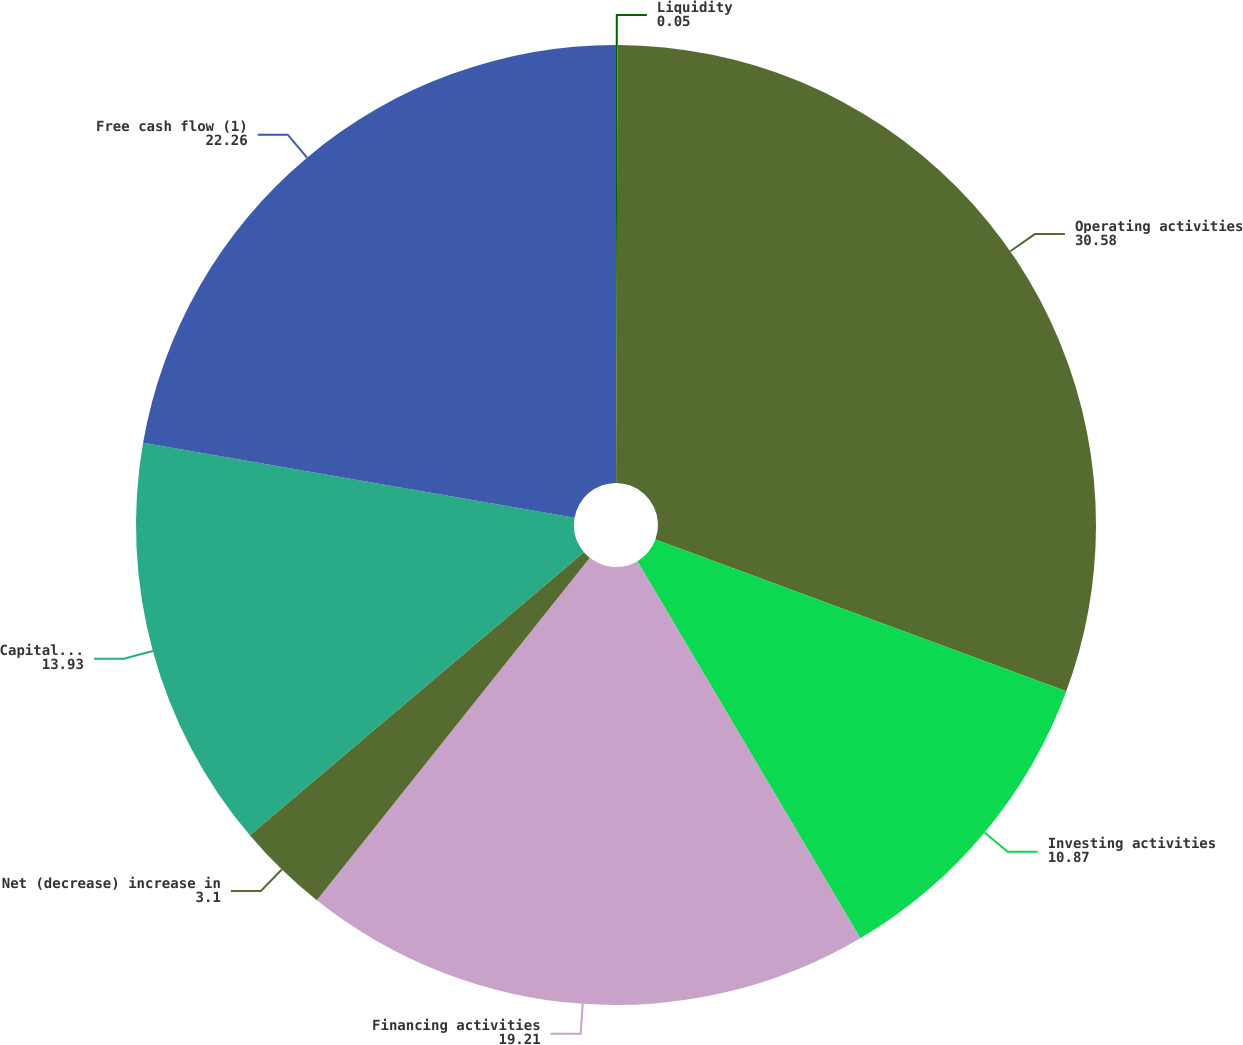Convert chart. <chart><loc_0><loc_0><loc_500><loc_500><pie_chart><fcel>Liquidity<fcel>Operating activities<fcel>Investing activities<fcel>Financing activities<fcel>Net (decrease) increase in<fcel>Capital expenditures<fcel>Free cash flow (1)<nl><fcel>0.05%<fcel>30.58%<fcel>10.87%<fcel>19.21%<fcel>3.1%<fcel>13.93%<fcel>22.26%<nl></chart> 